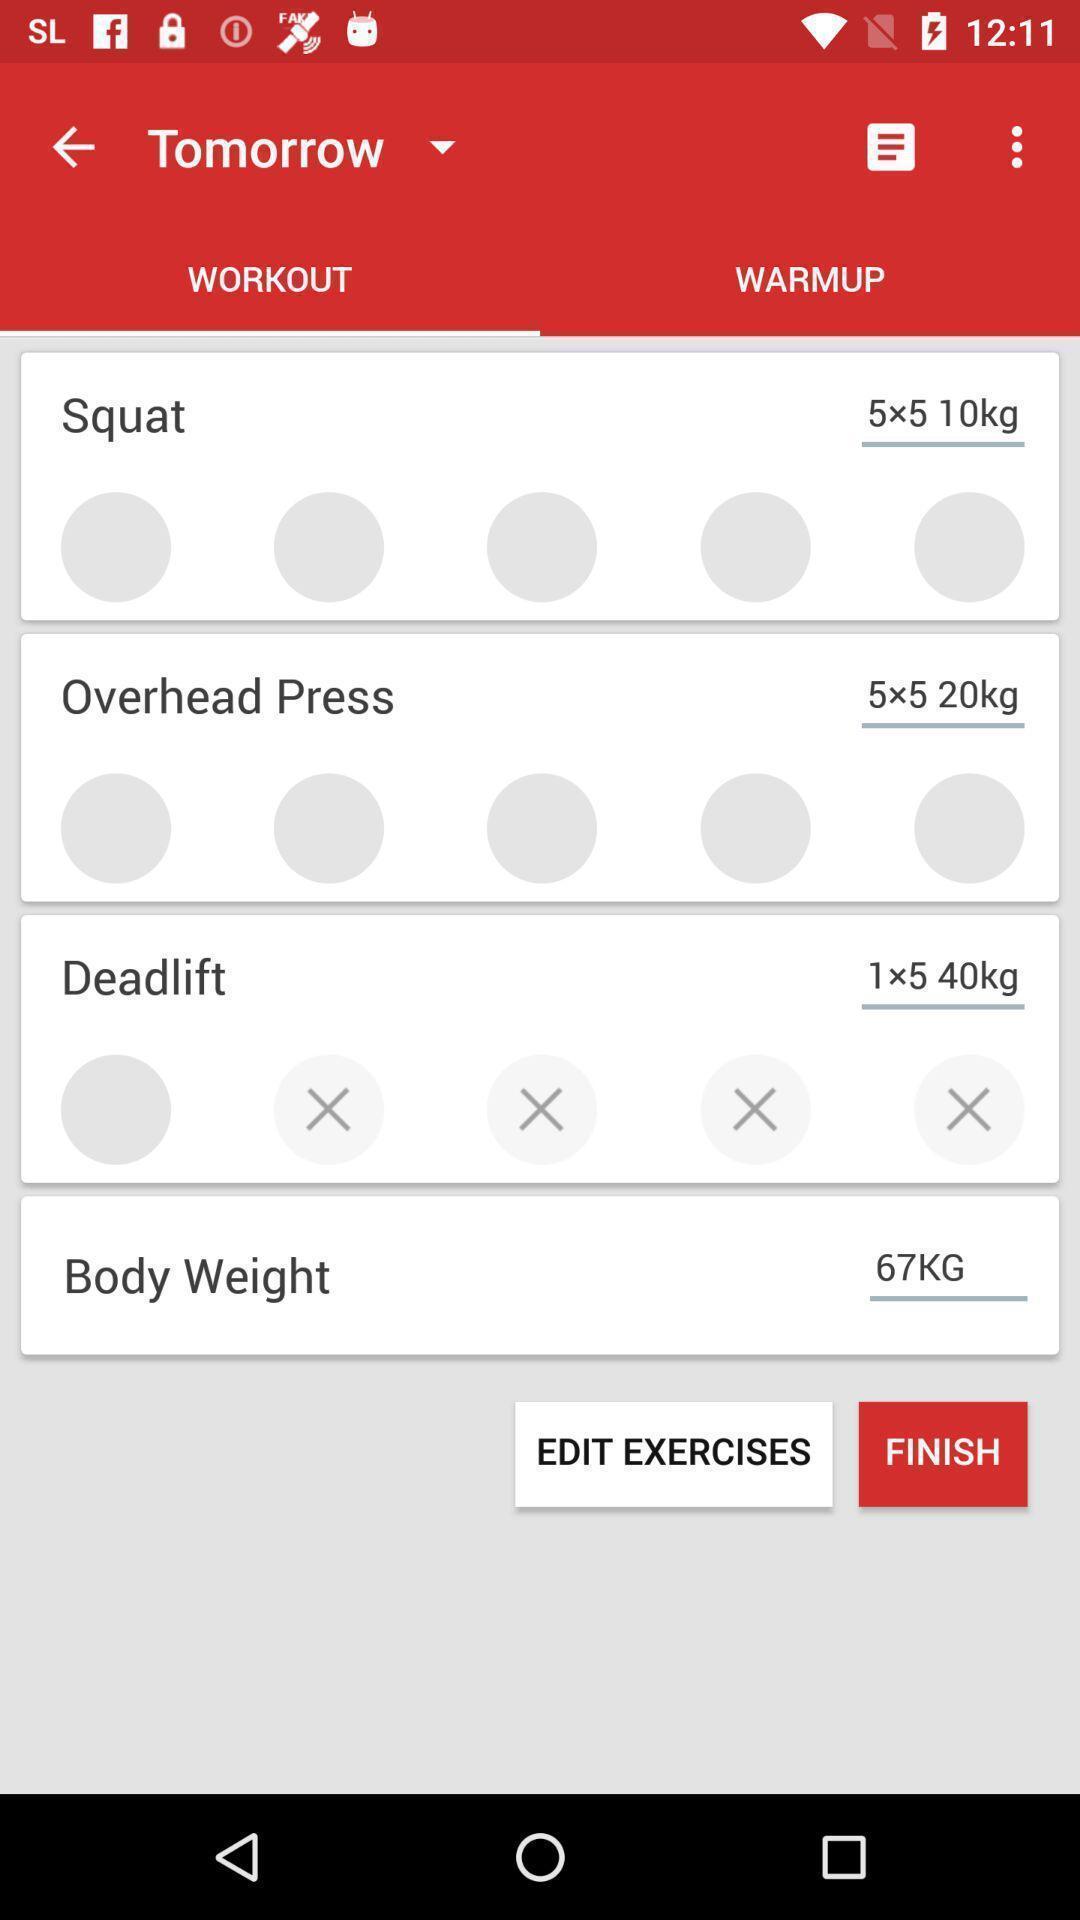Provide a detailed account of this screenshot. Set of options in workout page of a health app. 